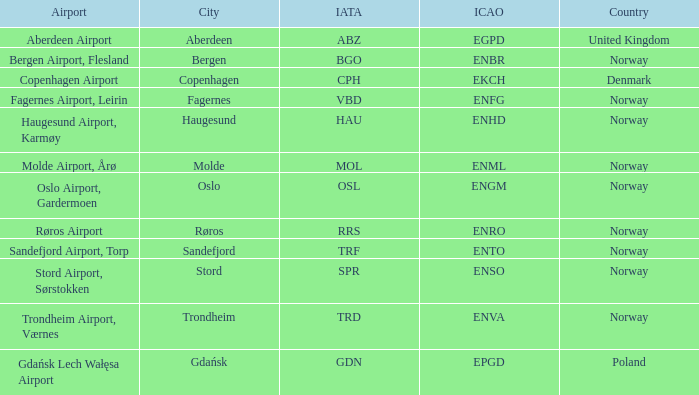What is City of Sandefjord in Norway's IATA? TRF. 